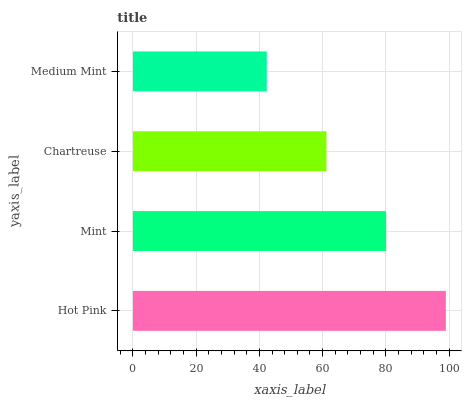Is Medium Mint the minimum?
Answer yes or no. Yes. Is Hot Pink the maximum?
Answer yes or no. Yes. Is Mint the minimum?
Answer yes or no. No. Is Mint the maximum?
Answer yes or no. No. Is Hot Pink greater than Mint?
Answer yes or no. Yes. Is Mint less than Hot Pink?
Answer yes or no. Yes. Is Mint greater than Hot Pink?
Answer yes or no. No. Is Hot Pink less than Mint?
Answer yes or no. No. Is Mint the high median?
Answer yes or no. Yes. Is Chartreuse the low median?
Answer yes or no. Yes. Is Chartreuse the high median?
Answer yes or no. No. Is Hot Pink the low median?
Answer yes or no. No. 